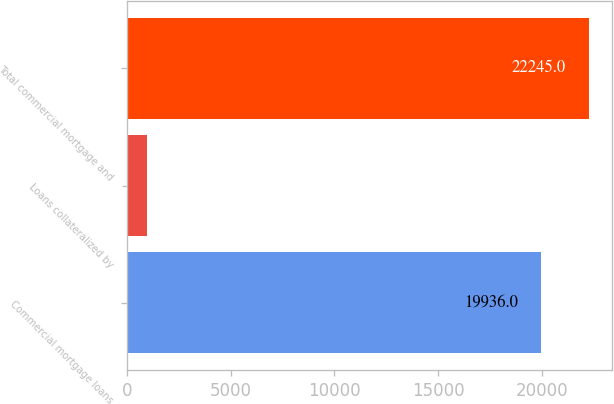Convert chart. <chart><loc_0><loc_0><loc_500><loc_500><bar_chart><fcel>Commercial mortgage loans<fcel>Loans collateralized by<fcel>Total commercial mortgage and<nl><fcel>19936<fcel>976<fcel>22245<nl></chart> 